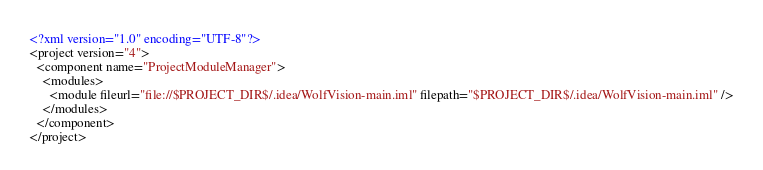Convert code to text. <code><loc_0><loc_0><loc_500><loc_500><_XML_><?xml version="1.0" encoding="UTF-8"?>
<project version="4">
  <component name="ProjectModuleManager">
    <modules>
      <module fileurl="file://$PROJECT_DIR$/.idea/WolfVision-main.iml" filepath="$PROJECT_DIR$/.idea/WolfVision-main.iml" />
    </modules>
  </component>
</project></code> 